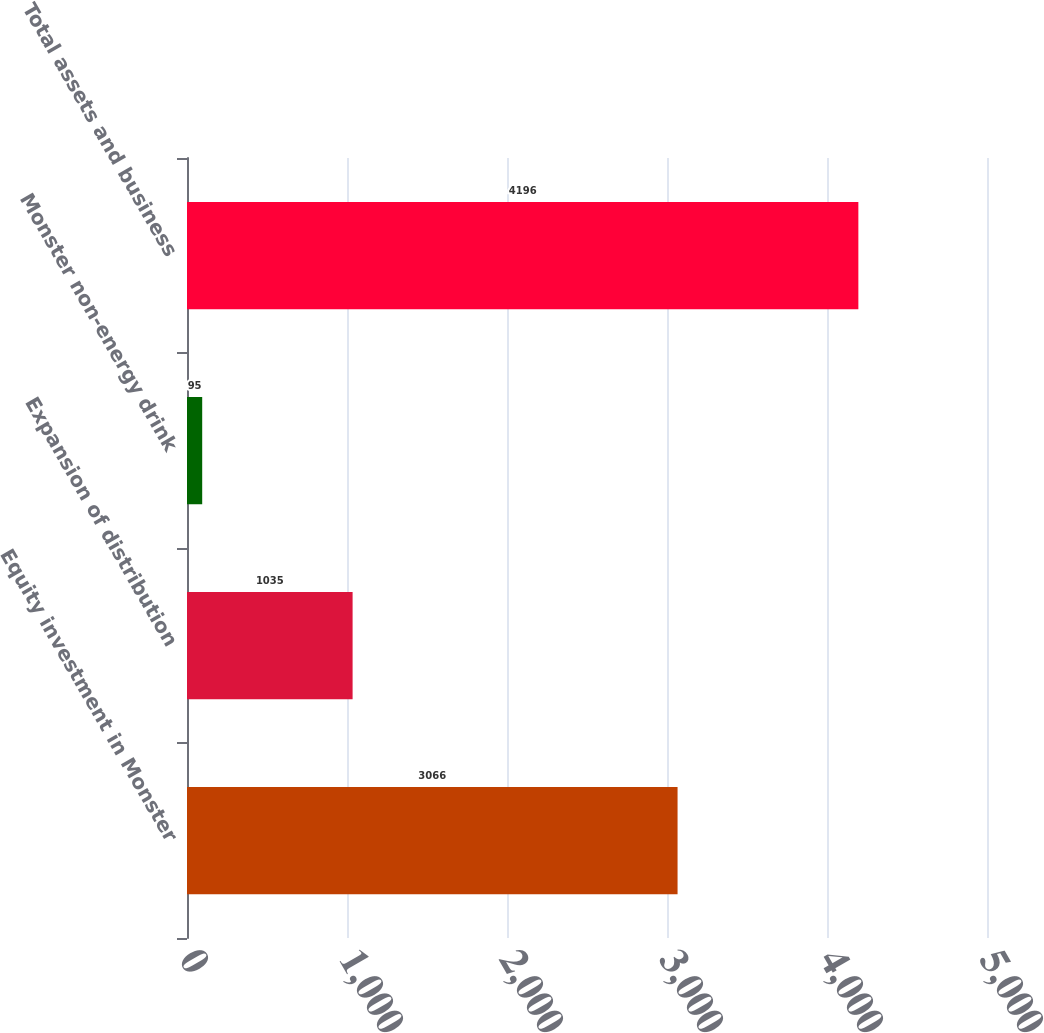Convert chart to OTSL. <chart><loc_0><loc_0><loc_500><loc_500><bar_chart><fcel>Equity investment in Monster<fcel>Expansion of distribution<fcel>Monster non-energy drink<fcel>Total assets and business<nl><fcel>3066<fcel>1035<fcel>95<fcel>4196<nl></chart> 